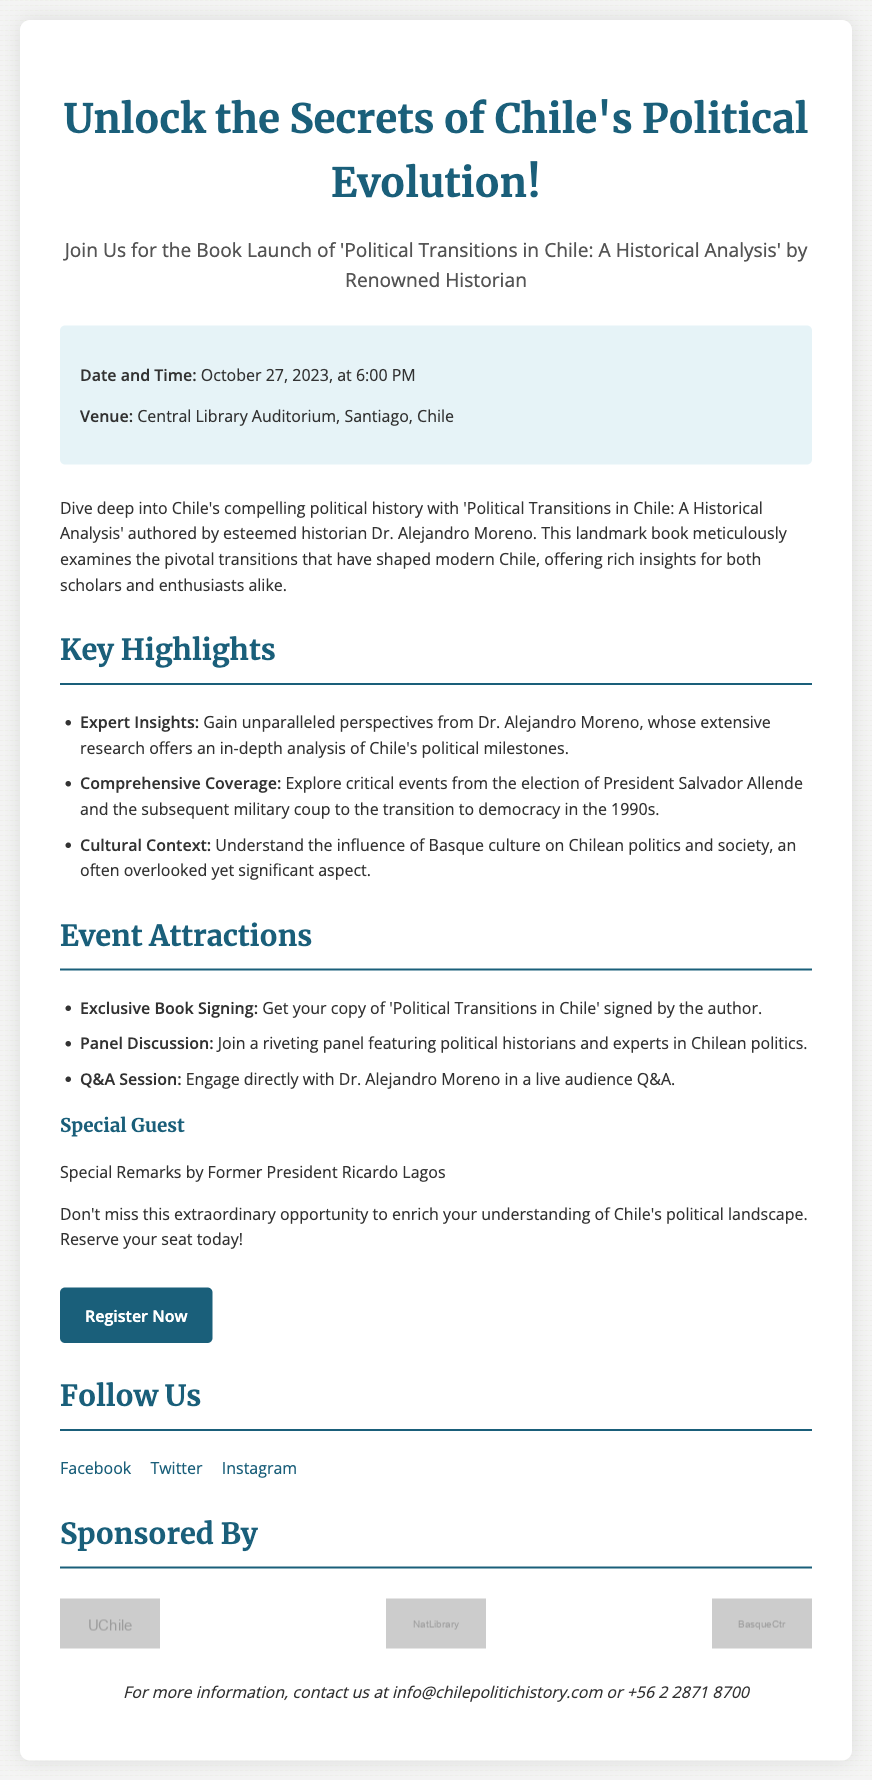What is the title of the book? The title of the book is explicitly mentioned in the document as 'Political Transitions in Chile: A Historical Analysis'.
Answer: Political Transitions in Chile: A Historical Analysis Who is the author of the book? The author of the book is mentioned as Dr. Alejandro Moreno in the document.
Answer: Dr. Alejandro Moreno What is the date of the book launch event? The document specifies the date of the book launch event as October 27, 2023.
Answer: October 27, 2023 Where will the event take place? The document states that the venue for the event is the Central Library Auditorium, Santiago, Chile.
Answer: Central Library Auditorium, Santiago, Chile What is one feature of the event? The document lists "Exclusive Book Signing" as one of the event attractions.
Answer: Exclusive Book Signing Which former president will give special remarks? The document mentions that Former President Ricardo Lagos will give special remarks at the event.
Answer: Former President Ricardo Lagos What time does the event start? The starting time of the event is mentioned as 6:00 PM in the document.
Answer: 6:00 PM What type of discussion will be held during the event? The document states there will be a "Panel Discussion" featuring political historians and experts.
Answer: Panel Discussion Which cultural influence is discussed in the book? The document notes that it explores the influence of Basque culture on Chilean politics and society.
Answer: Basque culture 